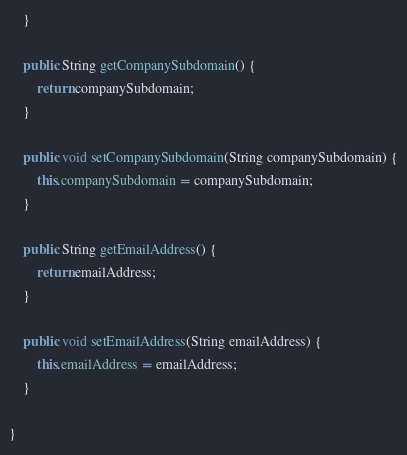<code> <loc_0><loc_0><loc_500><loc_500><_Java_>	}

	public String getCompanySubdomain() {
		return companySubdomain;
	}

	public void setCompanySubdomain(String companySubdomain) {
		this.companySubdomain = companySubdomain;
	}

	public String getEmailAddress() {
		return emailAddress;
	}

	public void setEmailAddress(String emailAddress) {
		this.emailAddress = emailAddress;
	}

}
</code> 